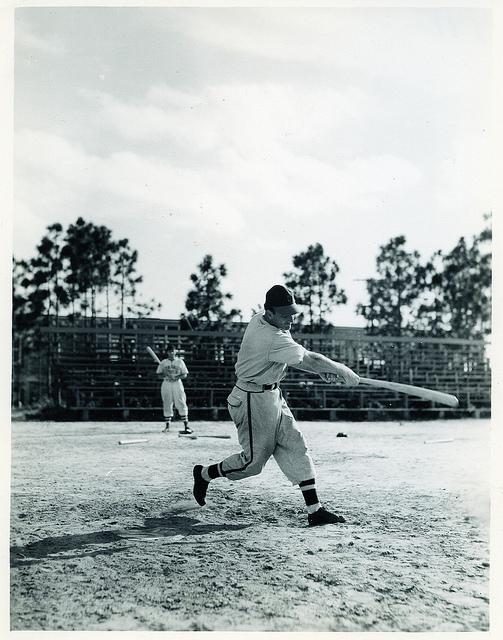Does the baseball player swing right or left handed?
Answer briefly. Right. Is there someone standing in the background?
Concise answer only. Yes. Did the man hit the ball?
Keep it brief. Yes. 